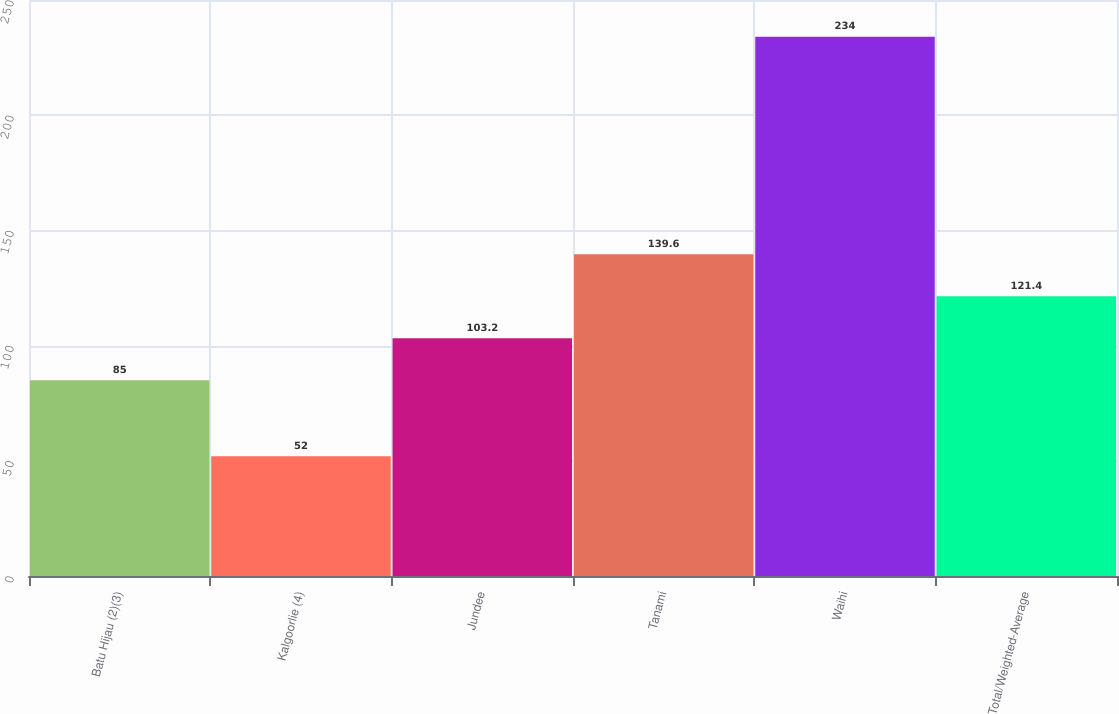<chart> <loc_0><loc_0><loc_500><loc_500><bar_chart><fcel>Batu Hijau (2)(3)<fcel>Kalgoorlie (4)<fcel>Jundee<fcel>Tanami<fcel>Waihi<fcel>Total/Weighted-Average<nl><fcel>85<fcel>52<fcel>103.2<fcel>139.6<fcel>234<fcel>121.4<nl></chart> 